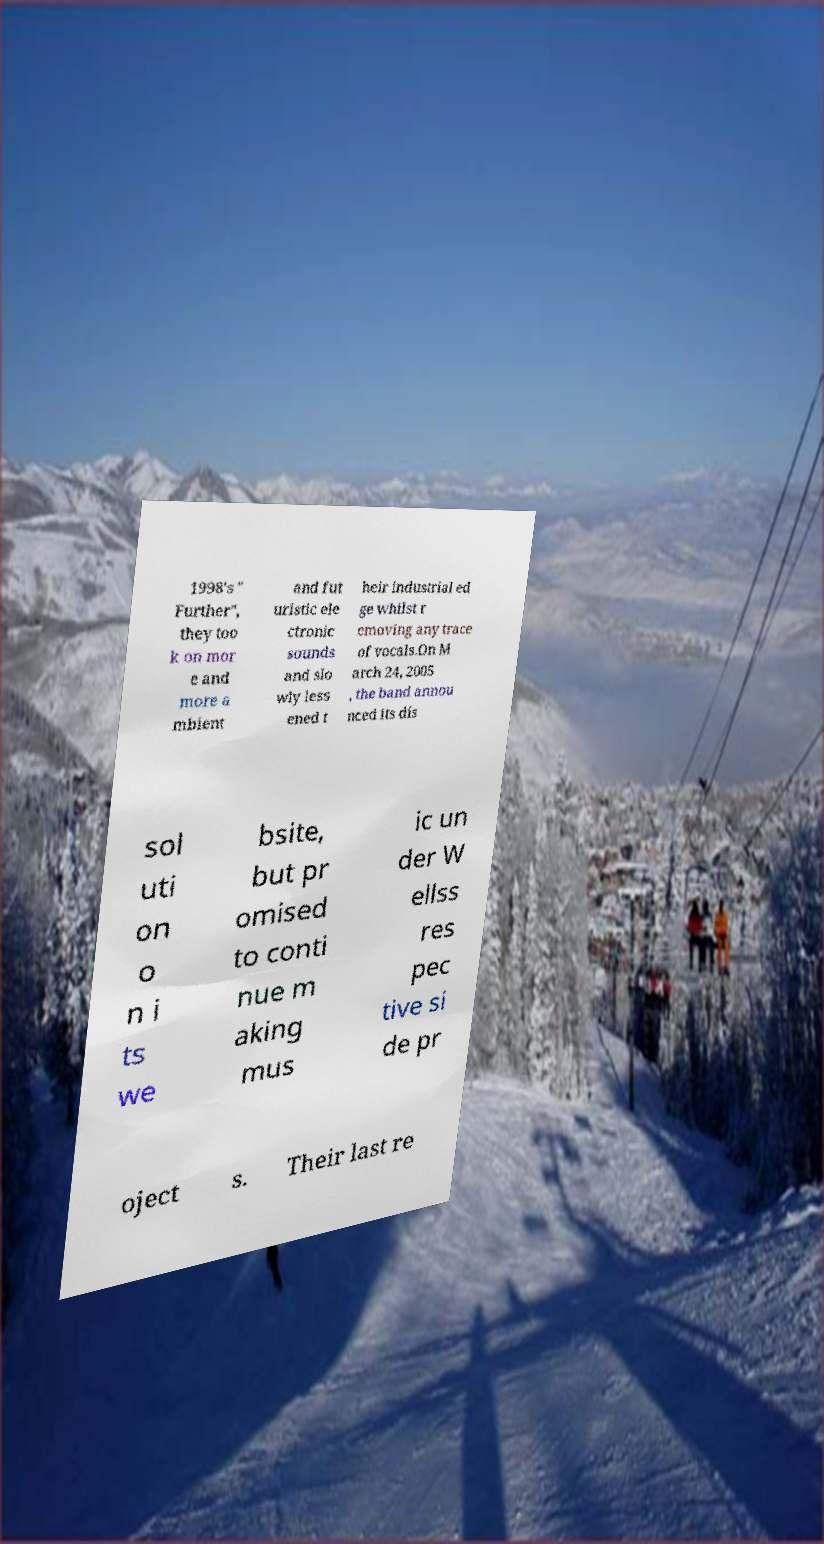Could you extract and type out the text from this image? 1998's " Further", they too k on mor e and more a mbient and fut uristic ele ctronic sounds and slo wly less ened t heir industrial ed ge whilst r emoving any trace of vocals.On M arch 24, 2005 , the band annou nced its dis sol uti on o n i ts we bsite, but pr omised to conti nue m aking mus ic un der W ellss res pec tive si de pr oject s. Their last re 